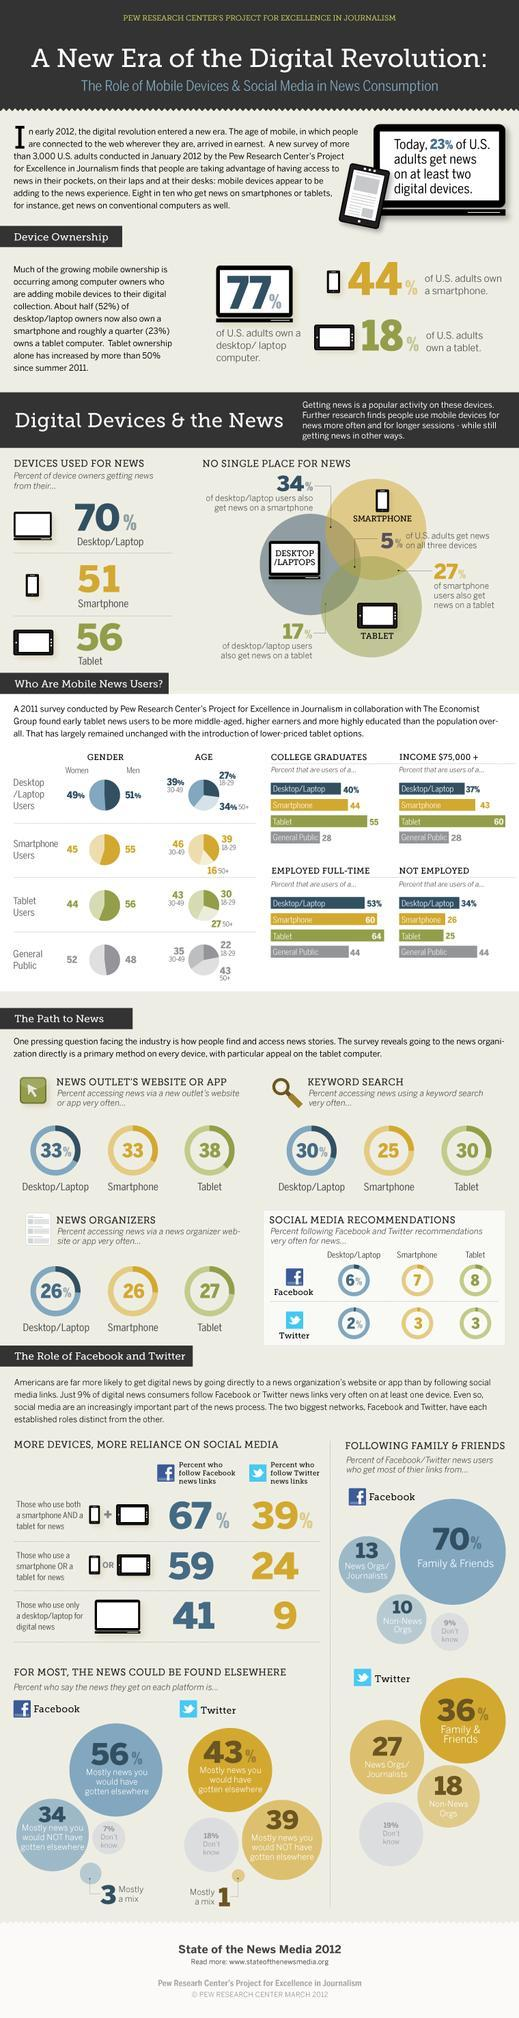What percent of tablet users follow facebook recommendations often for news according to the 2011 survey?
Answer the question with a short phrase. 8 What percent of the tablet news users are full-time employed according to the 2011 survey? 64 What percent of facebook news users get most of their links from their family & friends according to the survey conducted in the U.S. in January 2012? 70% What percentage of smartphone news users in the U.S. are women according to the 2011 survey? 45 What percentage of desktop or laptop users also get news on a tablet according to the survey conducted in the U.S. in January 2012? 17% What percentage of desktop/tablet news users in the U.S. are men according to the 2011 survey? 51% What percentage of smartphone news users are college graduates according to the 2011 survey? 44 What percentage of Americans access news using keyword search in their tablets according to the survey conducted in the U.S. in January 2012? 30 What percentage of Americans access news through smartphones according to the survey conducted in the U.S. in January 2012? 51 